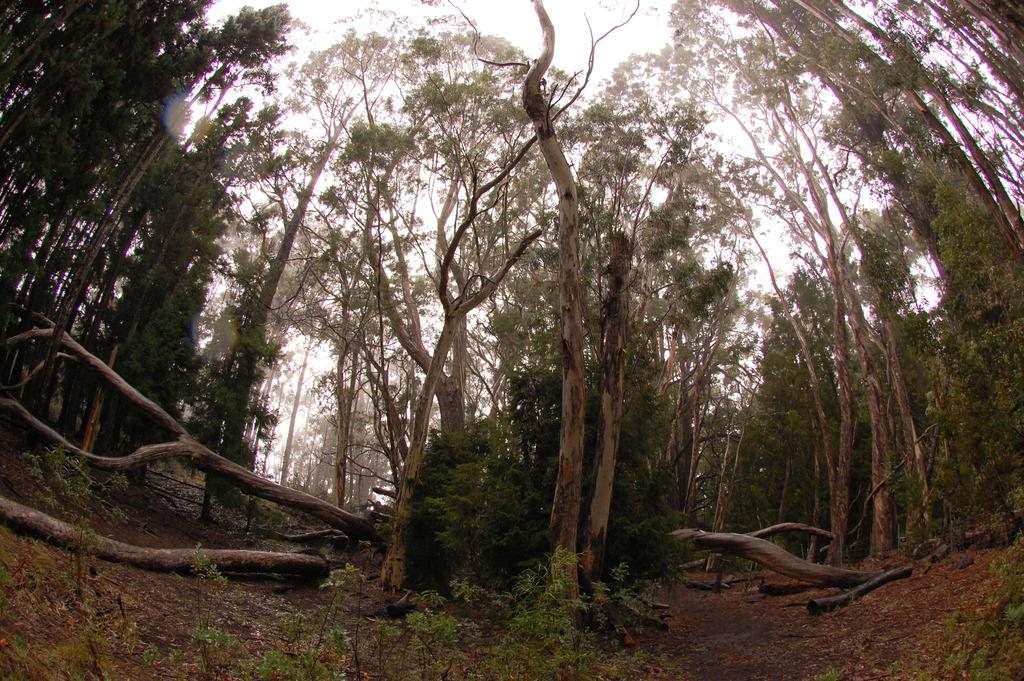What type of vegetation can be seen in the image? There are trees, grass, and plants in the image. What is the condition of the trees on the ground in the image? There are cut down trees on the ground in the image. What part of the natural environment is visible in the image? The sky is visible in the image. What type of detail can be seen on the wrist of the person in the image? There is no person present in the image, so it is not possible to determine any details about their wrist. 